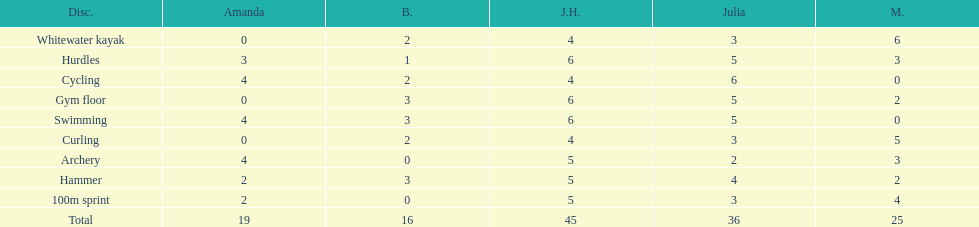Who scored the least on whitewater kayak? Amanda. 